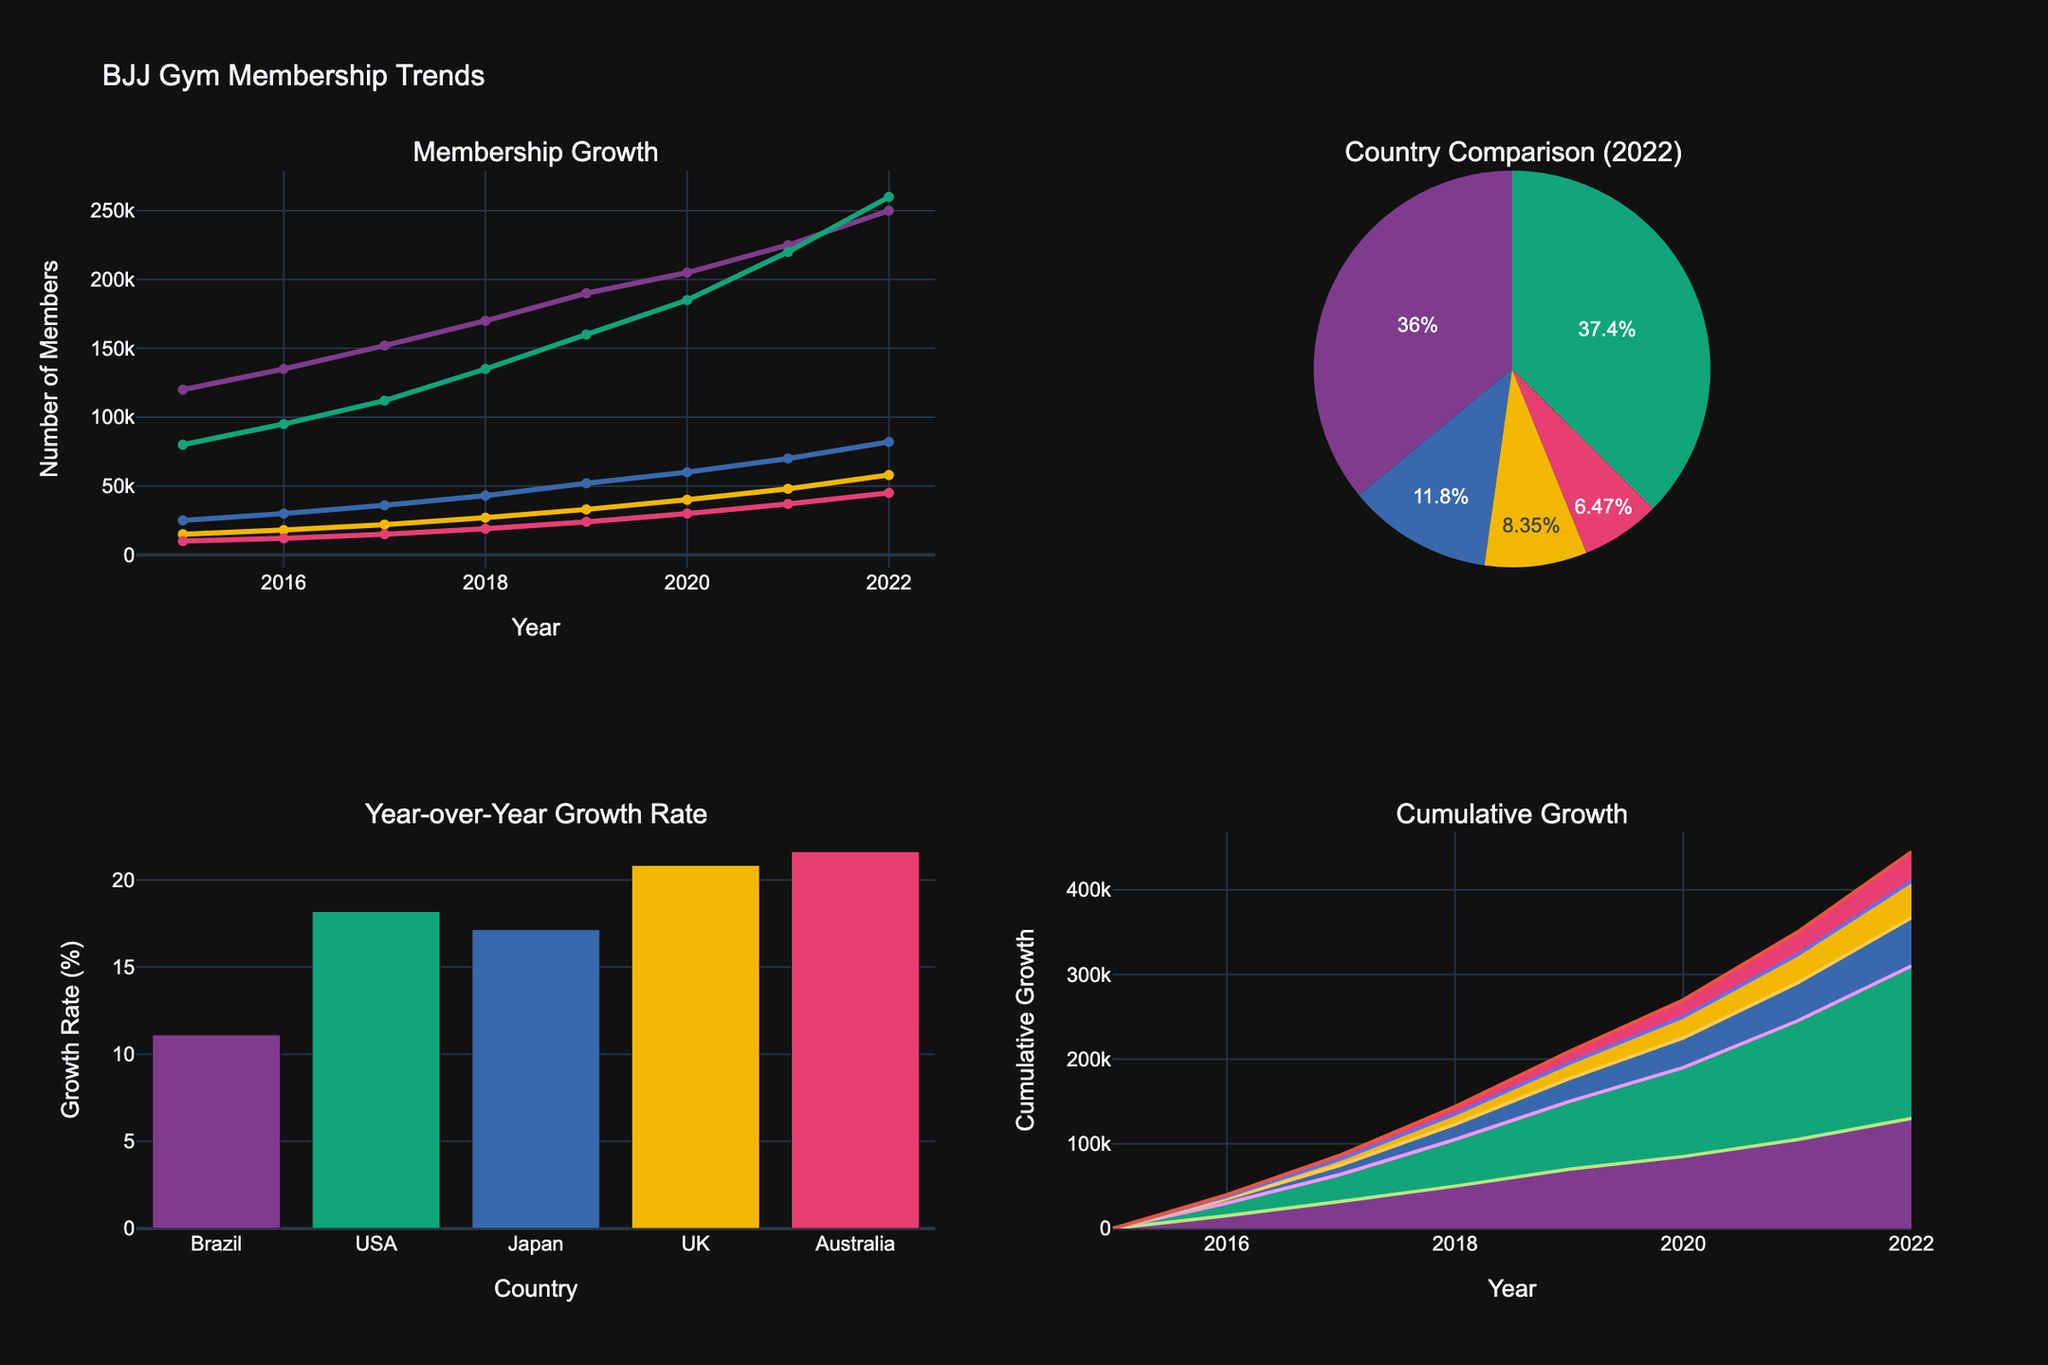What is the title of the figure? The title is displayed at the top of the figure and provides an overview of what the figure represents.
Answer: BJJ Gym Membership Trends Which country has the highest number of BJJ gym members in 2022? According to the pie chart, the size of the slice representing 'USA' is the largest indicating USA has the highest membership.
Answer: USA How many members did Brazil have in 2017? Refer to the line chart on subplot 1 (Membership Growth), trace the point corresponding to Brazil in 2017 on the x-axis and read the y-axis value.
Answer: 152,000 What is the growth rate of Japan from 2021 to 2022? From the bar chart in subplot 3, the growth rate in reverse percent change for Japan can be found. It's approximately 17.14%.
Answer: 17.14% Between Brazil and the USA, which country saw a higher cumulative growth over the entire period? Refer to the area chart in subplot 4. The area under Brazil's line is larger than that under USA's line, showing more cumulative growth for Brazil.
Answer: Brazil What's the overall trend of BJJ gym membership in the UK from 2015 to 2022? Diagram 1 shows a steady increasing trend for the UK from 2015 through 2022.
Answer: Increasing In 2022, how does the membership of BJJ gyms in Australia compare to those in the UK? Use the pie chart to compare the relative sizes of the slices for Australia and the UK; Australia's slice is slightly smaller than the UK's slice.
Answer: Smaller What is the cumulative growth for Australia from 2015 to 2022? The area chart indicates how many members were added since 2015; read the vertical distance for Australia.
Answer: 35,000 What can be inferred about the year-over-year growth rate distribution among the countries? The bar chart shows varied growth rates with the highest for the USA and the lowest for Australia, indicating different speeds of membership increase.
Answer: Varied By how much did Brazil's membership grow from 2015 to 2022? Subtract the membership in 2015 from the membership in 2022 for Brazil: 250,000 - 120,000 = 130,000.
Answer: 130,000 